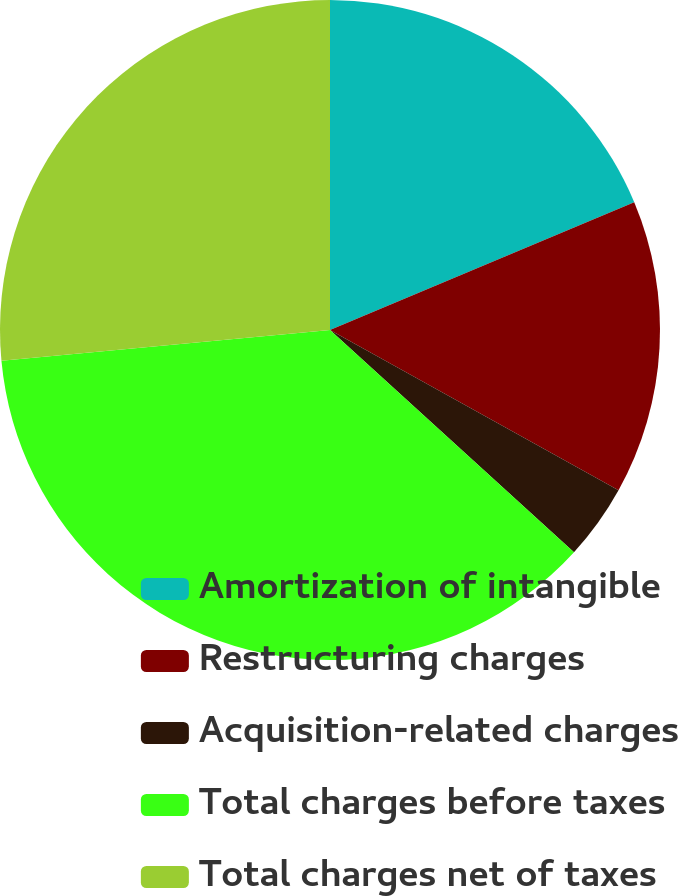Convert chart to OTSL. <chart><loc_0><loc_0><loc_500><loc_500><pie_chart><fcel>Amortization of intangible<fcel>Restructuring charges<fcel>Acquisition-related charges<fcel>Total charges before taxes<fcel>Total charges net of taxes<nl><fcel>18.67%<fcel>14.4%<fcel>3.69%<fcel>36.76%<fcel>26.49%<nl></chart> 